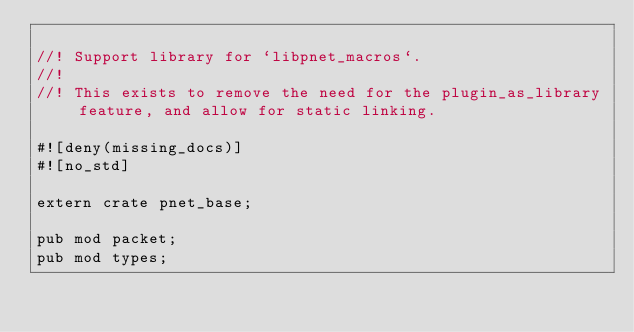<code> <loc_0><loc_0><loc_500><loc_500><_Rust_>
//! Support library for `libpnet_macros`.
//!
//! This exists to remove the need for the plugin_as_library feature, and allow for static linking.

#![deny(missing_docs)]
#![no_std]

extern crate pnet_base;

pub mod packet;
pub mod types;
</code> 